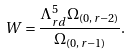Convert formula to latex. <formula><loc_0><loc_0><loc_500><loc_500>W = \frac { \Lambda _ { r d } ^ { 5 } \Omega _ { ( 0 , \, r - 2 ) } } { \Omega _ { ( 0 , \, r - 1 ) } } .</formula> 